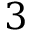<formula> <loc_0><loc_0><loc_500><loc_500>3</formula> 